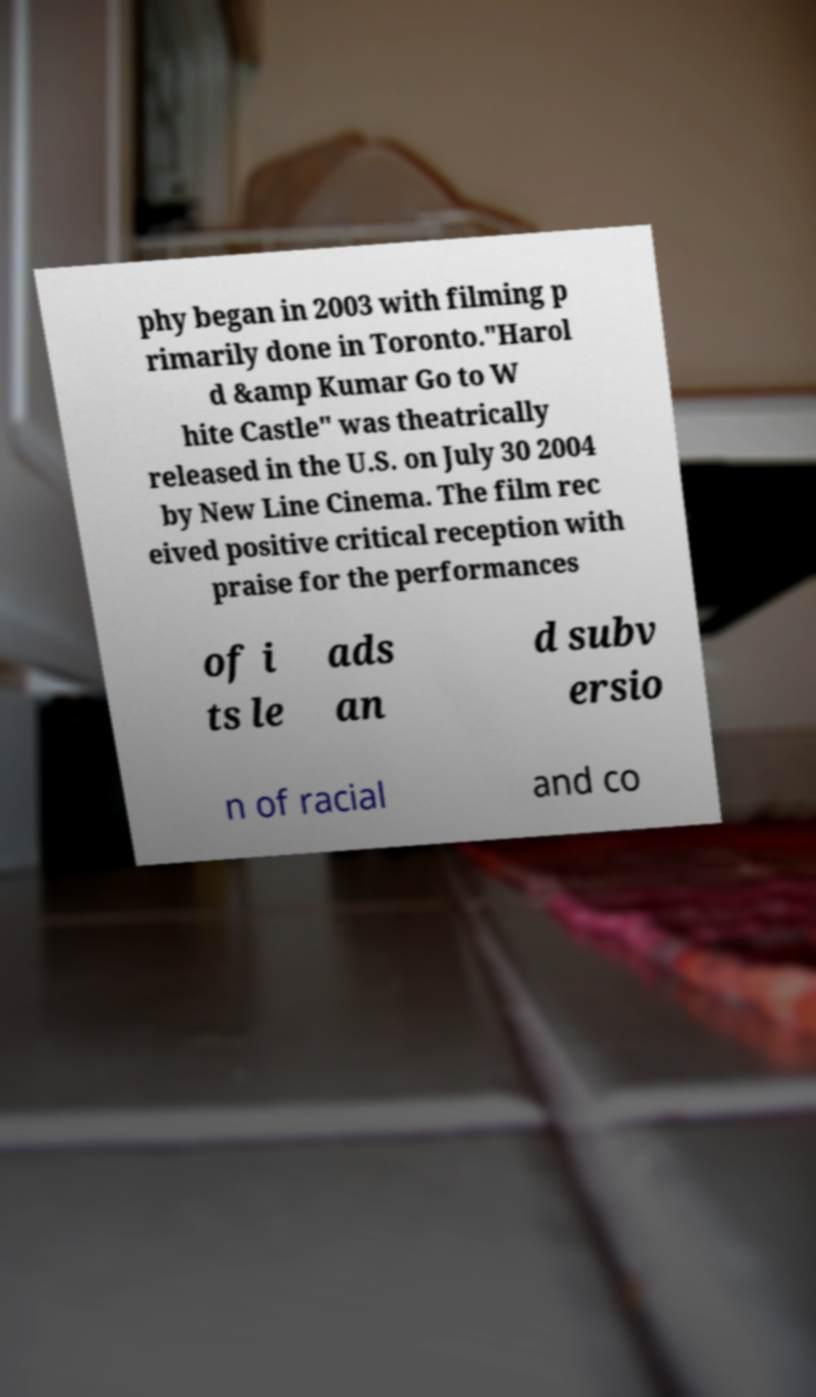Please read and relay the text visible in this image. What does it say? phy began in 2003 with filming p rimarily done in Toronto."Harol d &amp Kumar Go to W hite Castle" was theatrically released in the U.S. on July 30 2004 by New Line Cinema. The film rec eived positive critical reception with praise for the performances of i ts le ads an d subv ersio n of racial and co 